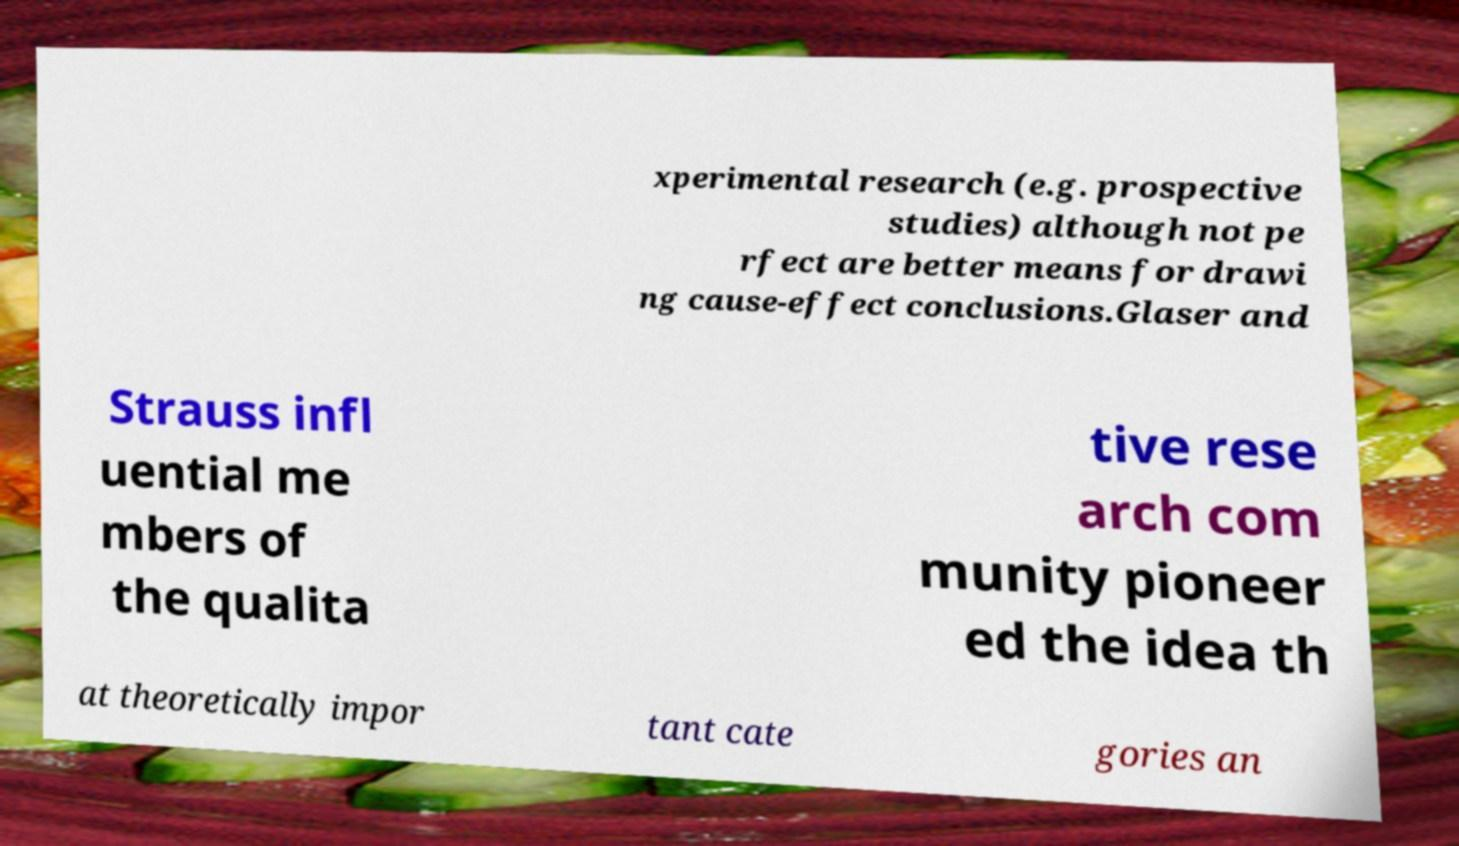What messages or text are displayed in this image? I need them in a readable, typed format. xperimental research (e.g. prospective studies) although not pe rfect are better means for drawi ng cause-effect conclusions.Glaser and Strauss infl uential me mbers of the qualita tive rese arch com munity pioneer ed the idea th at theoretically impor tant cate gories an 